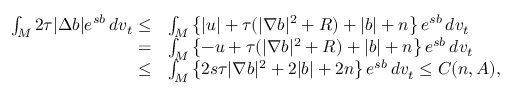<formula> <loc_0><loc_0><loc_500><loc_500>\begin{array} { r l } { \int _ { M } 2 \tau | \Delta b | e ^ { s b } \, d v _ { t } \leq } & { \int _ { M } \left \{ | u | + \tau ( | \nabla b | ^ { 2 } + R ) + | b | + n \right \} e ^ { s b } \, d v _ { t } } \\ { = } & { \int _ { M } \left \{ - u + \tau ( | \nabla b | ^ { 2 } + R ) + | b | + n \right \} e ^ { s b } \, d v _ { t } } \\ { \leq } & { \int _ { M } \left \{ 2 s \tau | \nabla b | ^ { 2 } + 2 | b | + 2 n \right \} e ^ { s b } \, d v _ { t } \leq C ( n , A ) , } \end{array}</formula> 